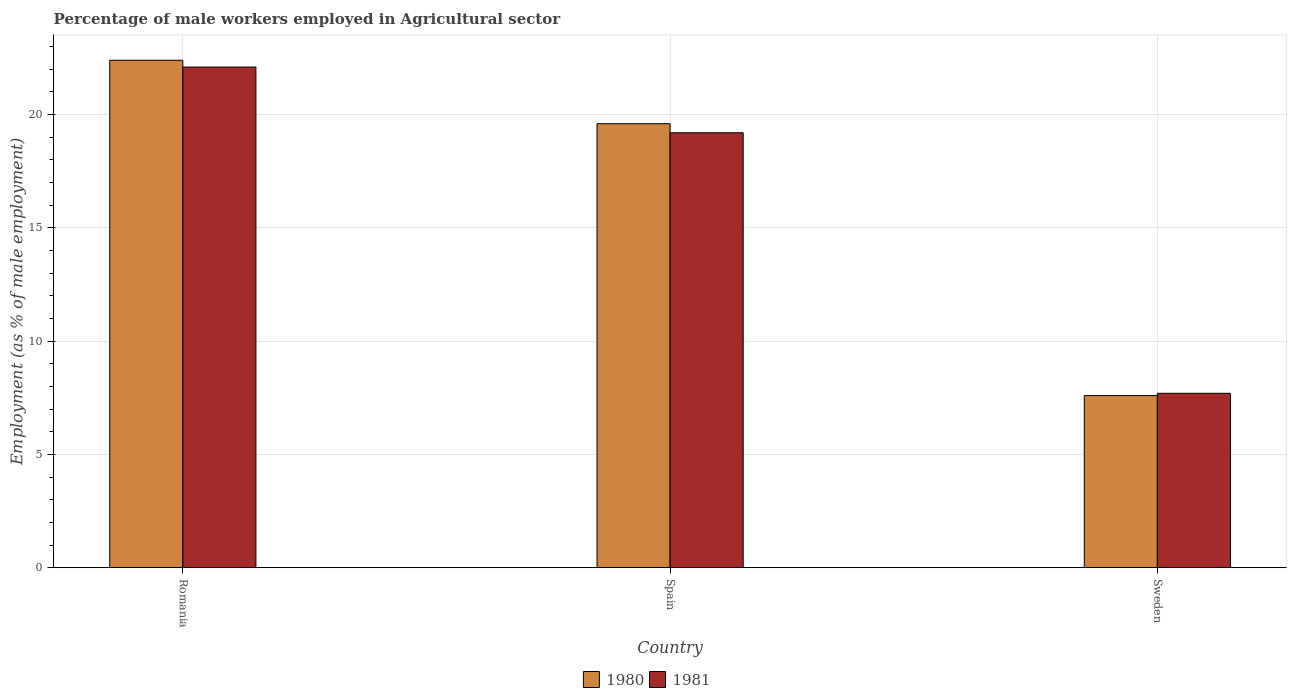How many different coloured bars are there?
Make the answer very short. 2. How many groups of bars are there?
Your answer should be compact. 3. Are the number of bars on each tick of the X-axis equal?
Provide a succinct answer. Yes. What is the percentage of male workers employed in Agricultural sector in 1981 in Spain?
Keep it short and to the point. 19.2. Across all countries, what is the maximum percentage of male workers employed in Agricultural sector in 1980?
Offer a terse response. 22.4. Across all countries, what is the minimum percentage of male workers employed in Agricultural sector in 1980?
Keep it short and to the point. 7.6. In which country was the percentage of male workers employed in Agricultural sector in 1980 maximum?
Offer a terse response. Romania. In which country was the percentage of male workers employed in Agricultural sector in 1980 minimum?
Your answer should be very brief. Sweden. What is the total percentage of male workers employed in Agricultural sector in 1980 in the graph?
Make the answer very short. 49.6. What is the difference between the percentage of male workers employed in Agricultural sector in 1981 in Spain and that in Sweden?
Your answer should be very brief. 11.5. What is the difference between the percentage of male workers employed in Agricultural sector in 1980 in Sweden and the percentage of male workers employed in Agricultural sector in 1981 in Spain?
Offer a terse response. -11.6. What is the average percentage of male workers employed in Agricultural sector in 1981 per country?
Offer a very short reply. 16.33. What is the difference between the percentage of male workers employed in Agricultural sector of/in 1981 and percentage of male workers employed in Agricultural sector of/in 1980 in Romania?
Make the answer very short. -0.3. What is the ratio of the percentage of male workers employed in Agricultural sector in 1981 in Spain to that in Sweden?
Keep it short and to the point. 2.49. What is the difference between the highest and the second highest percentage of male workers employed in Agricultural sector in 1980?
Your answer should be compact. -2.8. What is the difference between the highest and the lowest percentage of male workers employed in Agricultural sector in 1980?
Your answer should be very brief. 14.8. In how many countries, is the percentage of male workers employed in Agricultural sector in 1981 greater than the average percentage of male workers employed in Agricultural sector in 1981 taken over all countries?
Make the answer very short. 2. Is the sum of the percentage of male workers employed in Agricultural sector in 1981 in Spain and Sweden greater than the maximum percentage of male workers employed in Agricultural sector in 1980 across all countries?
Provide a succinct answer. Yes. Are all the bars in the graph horizontal?
Provide a succinct answer. No. What is the difference between two consecutive major ticks on the Y-axis?
Offer a terse response. 5. Does the graph contain grids?
Provide a succinct answer. Yes. Where does the legend appear in the graph?
Give a very brief answer. Bottom center. How many legend labels are there?
Ensure brevity in your answer.  2. What is the title of the graph?
Offer a very short reply. Percentage of male workers employed in Agricultural sector. What is the label or title of the X-axis?
Offer a very short reply. Country. What is the label or title of the Y-axis?
Provide a short and direct response. Employment (as % of male employment). What is the Employment (as % of male employment) of 1980 in Romania?
Offer a very short reply. 22.4. What is the Employment (as % of male employment) of 1981 in Romania?
Your answer should be compact. 22.1. What is the Employment (as % of male employment) of 1980 in Spain?
Offer a terse response. 19.6. What is the Employment (as % of male employment) of 1981 in Spain?
Keep it short and to the point. 19.2. What is the Employment (as % of male employment) in 1980 in Sweden?
Provide a succinct answer. 7.6. What is the Employment (as % of male employment) of 1981 in Sweden?
Offer a terse response. 7.7. Across all countries, what is the maximum Employment (as % of male employment) of 1980?
Your answer should be very brief. 22.4. Across all countries, what is the maximum Employment (as % of male employment) in 1981?
Offer a terse response. 22.1. Across all countries, what is the minimum Employment (as % of male employment) of 1980?
Your answer should be compact. 7.6. Across all countries, what is the minimum Employment (as % of male employment) in 1981?
Your answer should be very brief. 7.7. What is the total Employment (as % of male employment) of 1980 in the graph?
Ensure brevity in your answer.  49.6. What is the total Employment (as % of male employment) of 1981 in the graph?
Your answer should be very brief. 49. What is the difference between the Employment (as % of male employment) in 1981 in Romania and that in Spain?
Provide a succinct answer. 2.9. What is the difference between the Employment (as % of male employment) in 1980 in Romania and that in Sweden?
Ensure brevity in your answer.  14.8. What is the difference between the Employment (as % of male employment) in 1981 in Romania and that in Sweden?
Your answer should be compact. 14.4. What is the difference between the Employment (as % of male employment) in 1980 in Spain and that in Sweden?
Your answer should be very brief. 12. What is the difference between the Employment (as % of male employment) in 1981 in Spain and that in Sweden?
Keep it short and to the point. 11.5. What is the difference between the Employment (as % of male employment) in 1980 in Romania and the Employment (as % of male employment) in 1981 in Sweden?
Provide a short and direct response. 14.7. What is the average Employment (as % of male employment) in 1980 per country?
Provide a short and direct response. 16.53. What is the average Employment (as % of male employment) in 1981 per country?
Your answer should be compact. 16.33. What is the ratio of the Employment (as % of male employment) in 1980 in Romania to that in Spain?
Your answer should be very brief. 1.14. What is the ratio of the Employment (as % of male employment) in 1981 in Romania to that in Spain?
Provide a succinct answer. 1.15. What is the ratio of the Employment (as % of male employment) of 1980 in Romania to that in Sweden?
Keep it short and to the point. 2.95. What is the ratio of the Employment (as % of male employment) in 1981 in Romania to that in Sweden?
Your answer should be compact. 2.87. What is the ratio of the Employment (as % of male employment) of 1980 in Spain to that in Sweden?
Ensure brevity in your answer.  2.58. What is the ratio of the Employment (as % of male employment) of 1981 in Spain to that in Sweden?
Provide a short and direct response. 2.49. What is the difference between the highest and the second highest Employment (as % of male employment) in 1980?
Provide a short and direct response. 2.8. What is the difference between the highest and the second highest Employment (as % of male employment) of 1981?
Your answer should be very brief. 2.9. What is the difference between the highest and the lowest Employment (as % of male employment) of 1981?
Provide a short and direct response. 14.4. 